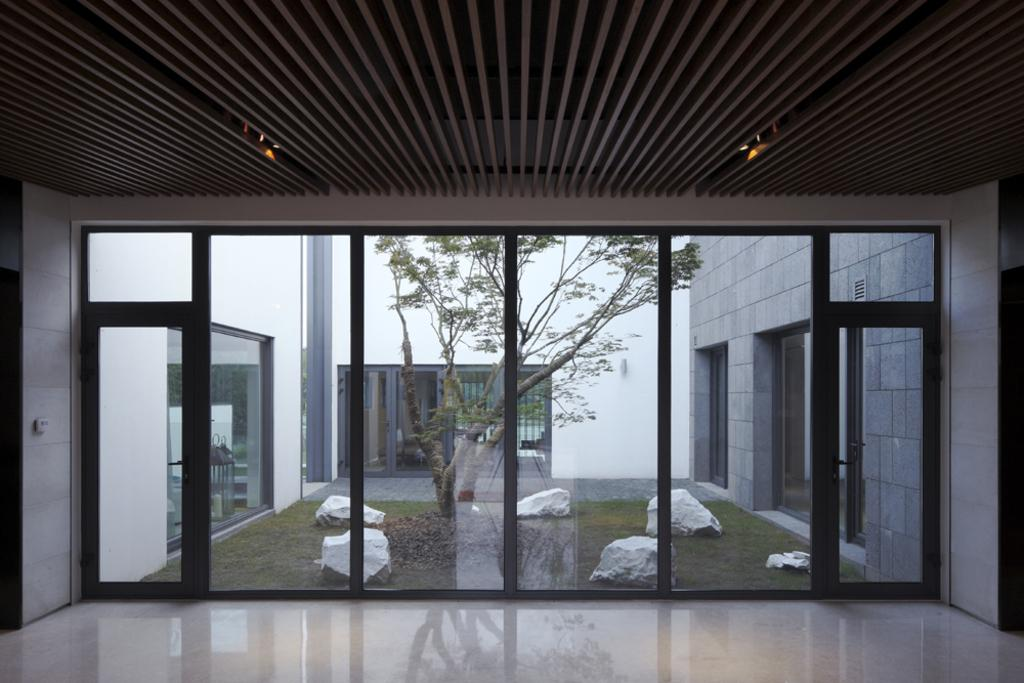What is above the objects in the image? There is a ceiling in the image. What provides illumination in the image? There are lights in the image. What is below the objects in the image? There is a floor in the image. What objects are used for drinking in the image? There are glasses in the image. What architectural features are present in the image? There are doors in the image. What can be seen through the glasses in the image? Trees, grass, and white color objects are visible through the glasses. What type of hair can be seen on the ghost in the image? There is no ghost present in the image, so there is no hair to describe. 